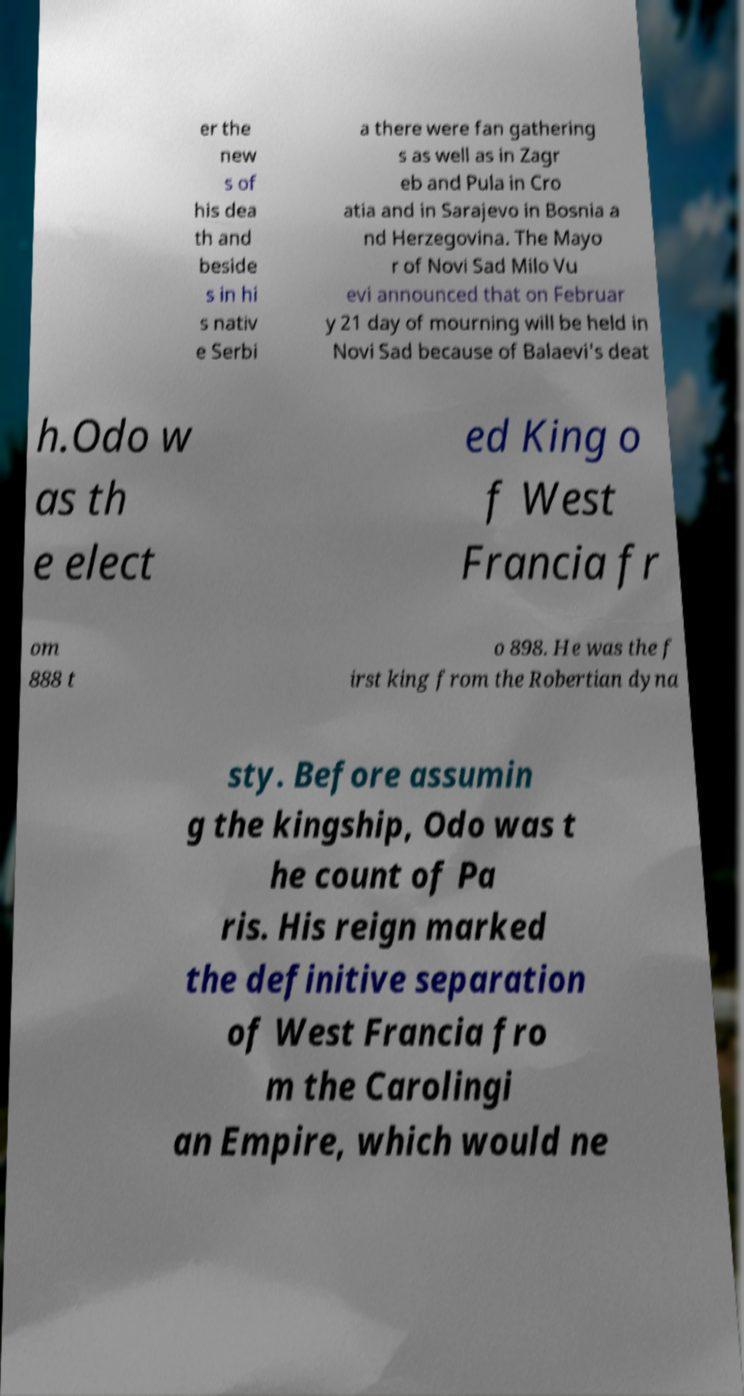For documentation purposes, I need the text within this image transcribed. Could you provide that? er the new s of his dea th and beside s in hi s nativ e Serbi a there were fan gathering s as well as in Zagr eb and Pula in Cro atia and in Sarajevo in Bosnia a nd Herzegovina. The Mayo r of Novi Sad Milo Vu evi announced that on Februar y 21 day of mourning will be held in Novi Sad because of Balaevi's deat h.Odo w as th e elect ed King o f West Francia fr om 888 t o 898. He was the f irst king from the Robertian dyna sty. Before assumin g the kingship, Odo was t he count of Pa ris. His reign marked the definitive separation of West Francia fro m the Carolingi an Empire, which would ne 